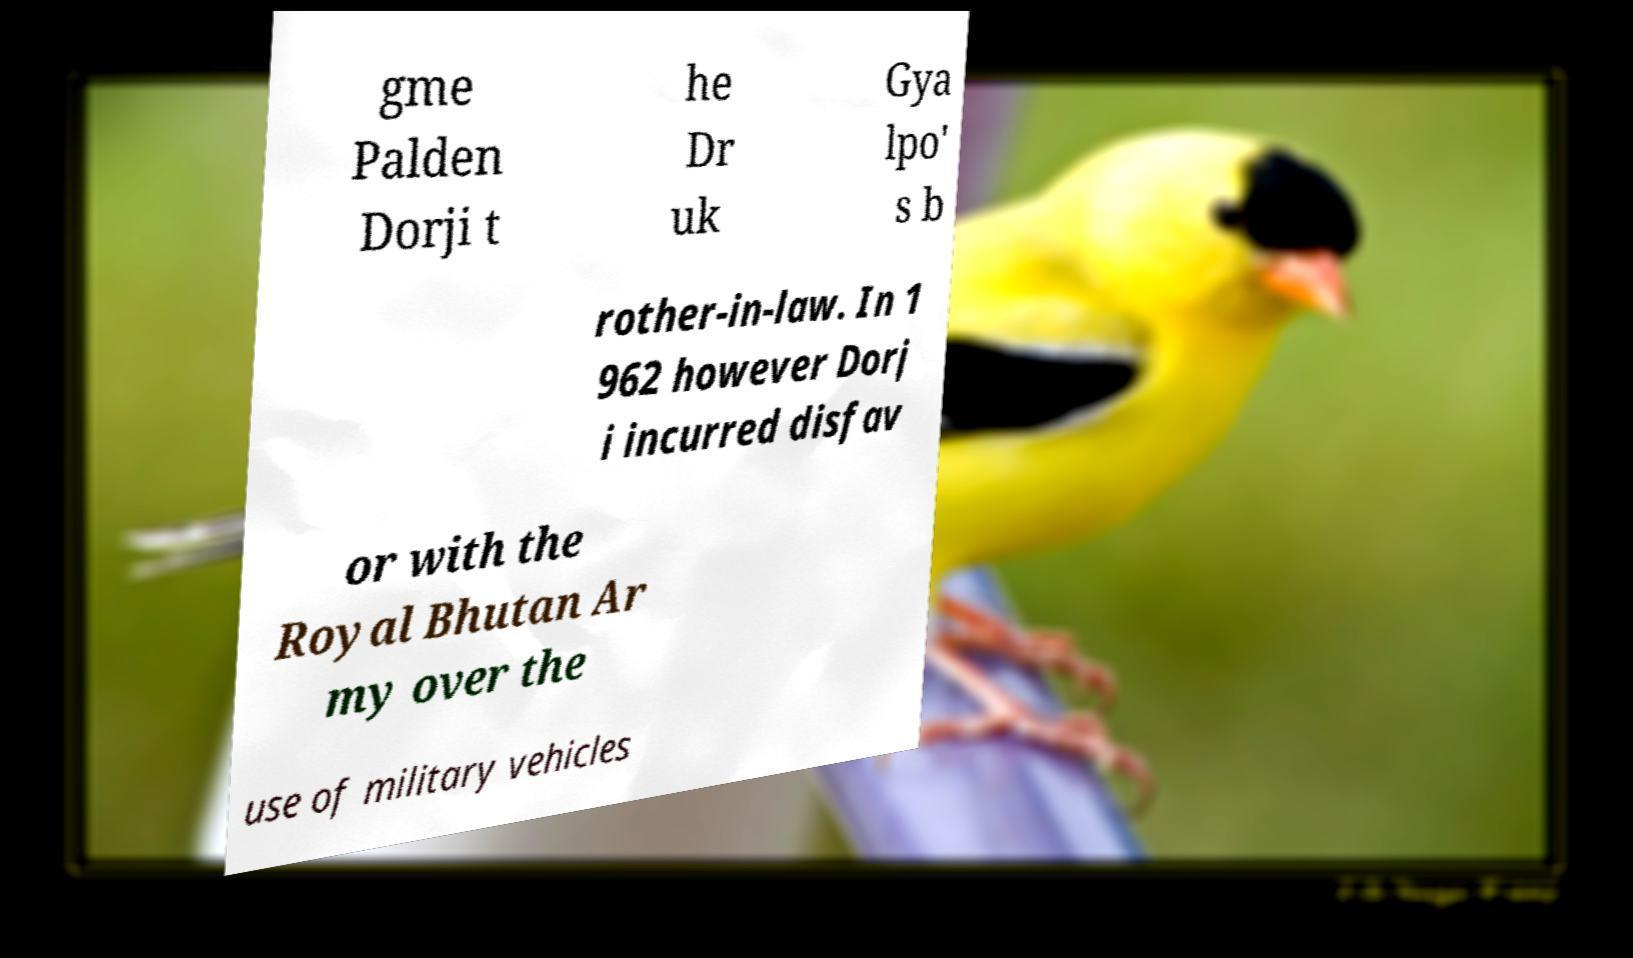Please identify and transcribe the text found in this image. gme Palden Dorji t he Dr uk Gya lpo' s b rother-in-law. In 1 962 however Dorj i incurred disfav or with the Royal Bhutan Ar my over the use of military vehicles 